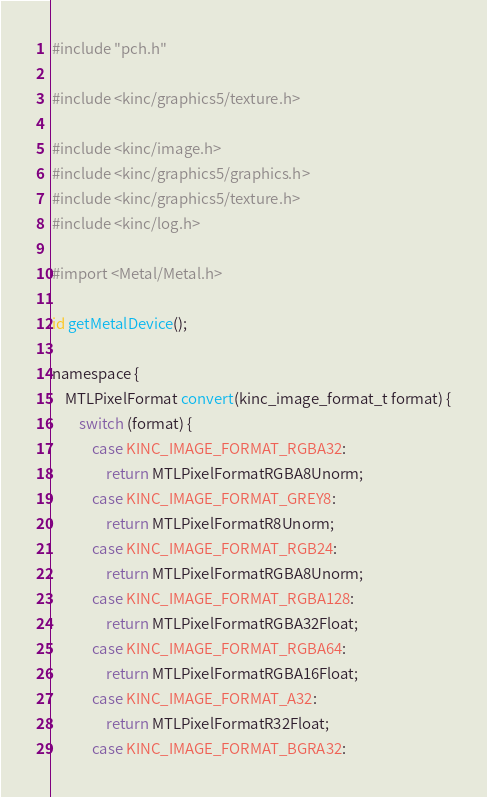Convert code to text. <code><loc_0><loc_0><loc_500><loc_500><_ObjectiveC_>#include "pch.h"

#include <kinc/graphics5/texture.h>

#include <kinc/image.h>
#include <kinc/graphics5/graphics.h>
#include <kinc/graphics5/texture.h>
#include <kinc/log.h>

#import <Metal/Metal.h>

id getMetalDevice();

namespace {
	MTLPixelFormat convert(kinc_image_format_t format) {
		switch (format) {
			case KINC_IMAGE_FORMAT_RGBA32:
				return MTLPixelFormatRGBA8Unorm;
			case KINC_IMAGE_FORMAT_GREY8:
				return MTLPixelFormatR8Unorm;
			case KINC_IMAGE_FORMAT_RGB24:
				return MTLPixelFormatRGBA8Unorm;
			case KINC_IMAGE_FORMAT_RGBA128:
				return MTLPixelFormatRGBA32Float;
			case KINC_IMAGE_FORMAT_RGBA64:
				return MTLPixelFormatRGBA16Float;
			case KINC_IMAGE_FORMAT_A32:
				return MTLPixelFormatR32Float;
			case KINC_IMAGE_FORMAT_BGRA32:</code> 